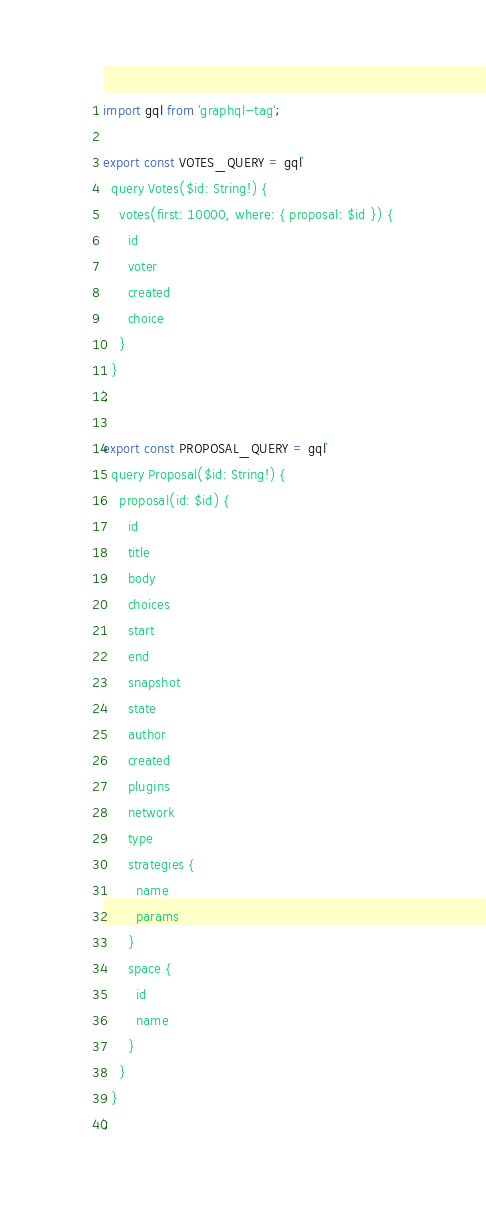<code> <loc_0><loc_0><loc_500><loc_500><_TypeScript_>import gql from 'graphql-tag';

export const VOTES_QUERY = gql`
  query Votes($id: String!) {
    votes(first: 10000, where: { proposal: $id }) {
      id
      voter
      created
      choice
    }
  }
`;

export const PROPOSAL_QUERY = gql`
  query Proposal($id: String!) {
    proposal(id: $id) {
      id
      title
      body
      choices
      start
      end
      snapshot
      state
      author
      created
      plugins
      network
      type
      strategies {
        name
        params
      }
      space {
        id
        name
      }
    }
  }
`;
</code> 